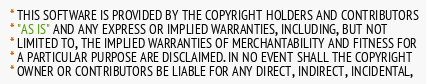Convert code to text. <code><loc_0><loc_0><loc_500><loc_500><_C_> * THIS SOFTWARE IS PROVIDED BY THE COPYRIGHT HOLDERS AND CONTRIBUTORS
 * "AS IS" AND ANY EXPRESS OR IMPLIED WARRANTIES, INCLUDING, BUT NOT
 * LIMITED TO, THE IMPLIED WARRANTIES OF MERCHANTABILITY AND FITNESS FOR
 * A PARTICULAR PURPOSE ARE DISCLAIMED. IN NO EVENT SHALL THE COPYRIGHT
 * OWNER OR CONTRIBUTORS BE LIABLE FOR ANY DIRECT, INDIRECT, INCIDENTAL,</code> 